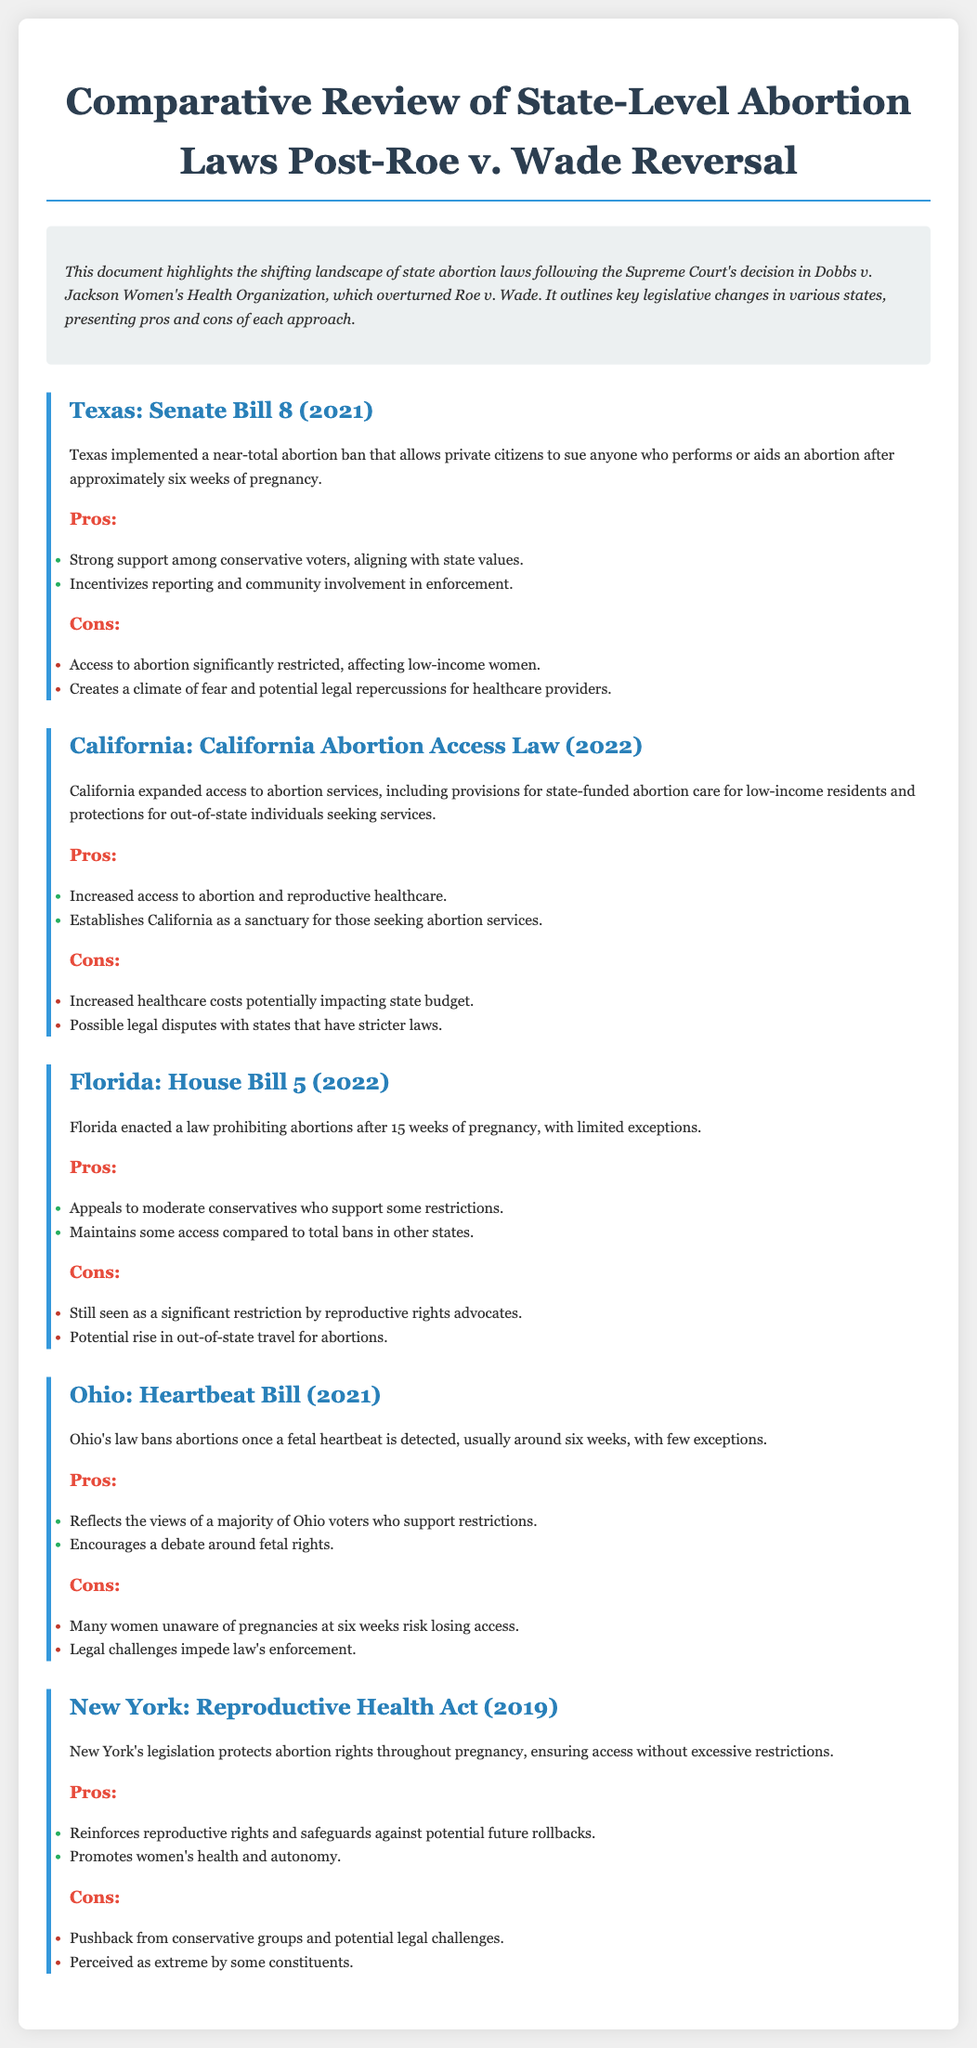What is the title of the document? The title of the document is stated in the header section.
Answer: Comparative Review of State-Level Abortion Laws Post-Roe v. Wade What law did Texas implement in 2021? The specific law referenced in the Texas section is noted.
Answer: Senate Bill 8 What is the main restriction of Florida's House Bill 5? The restriction imposed by Florida's law is clearly stated.
Answer: Prohibiting abortions after 15 weeks Which state is recognized as a sanctuary for abortion services? The document highlights California’s status for abortion services.
Answer: California What is one pro of Ohio's Heartbeat Bill? A pro of the bill reflecting voter opinion is provided.
Answer: Reflects the views of a majority of Ohio voters How many weeks after which a fetal heartbeat is detected does Ohio's law ban abortions? This information is crucial for understanding Ohio's law.
Answer: Six weeks What potential consequence does California's law pose for other states? The potential legal disputes with other states is mentioned.
Answer: Possible legal disputes with states that have stricter laws What do supporters of New York's Reproductive Health Act claim it promotes? The benefits of the law for women's health have been detailed.
Answer: Women's health and autonomy What is one con of Florida's House Bill 5? A potential downside of the law is provided in the document.
Answer: Still seen as a significant restriction by reproductive rights advocates 